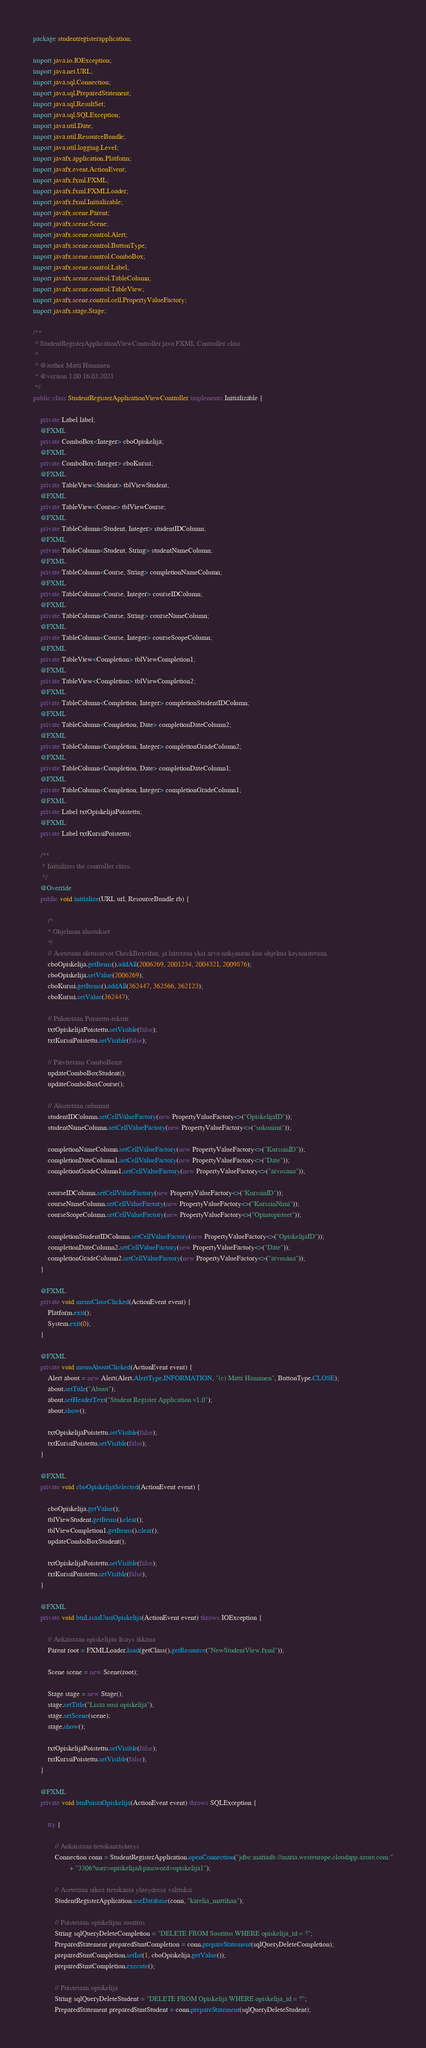<code> <loc_0><loc_0><loc_500><loc_500><_Java_>package studentregisterapplication;

import java.io.IOException;
import java.net.URL;
import java.sql.Connection;
import java.sql.PreparedStatement;
import java.sql.ResultSet;
import java.sql.SQLException;
import java.util.Date;
import java.util.ResourceBundle;
import java.util.logging.Level;
import javafx.application.Platform;
import javafx.event.ActionEvent;
import javafx.fxml.FXML;
import javafx.fxml.FXMLLoader;
import javafx.fxml.Initializable;
import javafx.scene.Parent;
import javafx.scene.Scene;
import javafx.scene.control.Alert;
import javafx.scene.control.ButtonType;
import javafx.scene.control.ComboBox;
import javafx.scene.control.Label;
import javafx.scene.control.TableColumn;
import javafx.scene.control.TableView;
import javafx.scene.control.cell.PropertyValueFactory;
import javafx.stage.Stage;

/**
 * StudentRegisterApplicationViewController.java FXML Controller class
 *
 * @author Matti Hanninen
 * @version 1.00 16.03.2021
 */
public class StudentRegisterApplicationViewController implements Initializable {

    private Label label;
    @FXML
    private ComboBox<Integer> cboOpiskelija;
    @FXML
    private ComboBox<Integer> cboKurssi;
    @FXML
    private TableView<Student> tblViewStudent;
    @FXML
    private TableView<Course> tblViewCourse;
    @FXML
    private TableColumn<Student, Integer> studentIDColumn;
    @FXML
    private TableColumn<Student, String> studentNameColumn;
    @FXML
    private TableColumn<Course, String> completionNameColumn;
    @FXML
    private TableColumn<Course, Integer> courseIDColumn;
    @FXML
    private TableColumn<Course, String> courseNameColumn;
    @FXML
    private TableColumn<Course, Integer> courseScopeColumn;
    @FXML
    private TableView<Completion> tblViewCompletion1;
    @FXML
    private TableView<Completion> tblViewCompletion2;
    @FXML
    private TableColumn<Completion, Integer> completionStudentIDColumn;
    @FXML
    private TableColumn<Completion, Date> completionDateColumn2;
    @FXML
    private TableColumn<Completion, Integer> completionGradeColumn2;
    @FXML
    private TableColumn<Completion, Date> completionDateColumn1;
    @FXML
    private TableColumn<Completion, Integer> completionGradeColumn1;
    @FXML
    private Label txtOpiskelijaPoistettu;
    @FXML
    private Label txtKurssiPoistettu;

    /**
     * Initializes the controller class.
     */
    @Override
    public void initialize(URL url, ResourceBundle rb) {

        /*
        * Ohjelman alustukset
        */
        // Asetetaan oletusarvot CheckBoxeihin, ja laitetaan yksi arvo nakymaan kun ohjelma kaynnistetaan.
        cboOpiskelija.getItems().addAll(2006269, 2001234, 2004321, 2009876);
        cboOpiskelija.setValue(2006269);
        cboKurssi.getItems().addAll(362447, 362566, 362123);
        cboKurssi.setValue(362447);

        // Piilotetaan Poistettu-tekstit
        txtOpiskelijaPoistettu.setVisible(false);
        txtKurssiPoistettu.setVisible(false);

        // Paivitetaan ComboBoxit
        updateComboBoxStudent();
        updateComboBoxCourse();

        // Alustetaan columnit
        studentIDColumn.setCellValueFactory(new PropertyValueFactory<>("OpiskelijaID"));
        studentNameColumn.setCellValueFactory(new PropertyValueFactory<>("sukunimi"));

        completionNameColumn.setCellValueFactory(new PropertyValueFactory<>("KurssinID"));
        completionDateColumn1.setCellValueFactory(new PropertyValueFactory<>("Date"));
        completionGradeColumn1.setCellValueFactory(new PropertyValueFactory<>("arvosana"));

        courseIDColumn.setCellValueFactory(new PropertyValueFactory<>("KurssinID"));
        courseNameColumn.setCellValueFactory(new PropertyValueFactory<>("KurssinNimi"));
        courseScopeColumn.setCellValueFactory(new PropertyValueFactory<>("Opintopisteet"));

        completionStudentIDColumn.setCellValueFactory(new PropertyValueFactory<>("OpiskelijaID"));
        completionDateColumn2.setCellValueFactory(new PropertyValueFactory<>("Date"));
        completionGradeColumn2.setCellValueFactory(new PropertyValueFactory<>("arvosana"));
    }

    @FXML
    private void menuCloseClicked(ActionEvent event) {
        Platform.exit();
        System.exit(0);
    }

    @FXML
    private void menuAboutClicked(ActionEvent event) {
        Alert about = new Alert(Alert.AlertType.INFORMATION, "(c) Matti Hanninen", ButtonType.CLOSE);
        about.setTitle("About");
        about.setHeaderText("Student Register Application v1.0");
        about.show();

        txtOpiskelijaPoistettu.setVisible(false);
        txtKurssiPoistettu.setVisible(false);
    }

    @FXML
    private void cboOpiskelijaSelected(ActionEvent event) {

        cboOpiskelija.getValue();
        tblViewStudent.getItems().clear();
        tblViewCompletion1.getItems().clear();
        updateComboBoxStudent();

        txtOpiskelijaPoistettu.setVisible(false);
        txtKurssiPoistettu.setVisible(false);
    }

    @FXML
    private void btnLisaaUusiOpiskelija(ActionEvent event) throws IOException {

        // Aukaistaan opiskelijan lisays ikkuna
        Parent root = FXMLLoader.load(getClass().getResource("NewStudentView.fxml"));

        Scene scene = new Scene(root);

        Stage stage = new Stage();
        stage.setTitle("Lisaa uusi opiskelija");
        stage.setScene(scene);
        stage.show();

        txtOpiskelijaPoistettu.setVisible(false);
        txtKurssiPoistettu.setVisible(false);
    }

    @FXML
    private void btnPoistaOpiskelija(ActionEvent event) throws SQLException {

        try {

            // Aukaistaan tietokantayhteys
            Connection conn = StudentRegisterApplication.openConnection("jdbc:mariadb://maria.westeurope.cloudapp.azure.com:"
                    + "3306?user=opiskelija&password=opiskelija1");

            // Asetetaan oikea tietokanta yhteydessa valituksi
            StudentRegisterApplication.useDatabase(conn, "karelia_mattihan");

            // Poistetaan opiskelijan suoritus
            String sqlQueryDeleteCompletion = "DELETE FROM Suoritus WHERE opiskelija_id = ?";
            PreparedStatement preparedStmtCompletion = conn.prepareStatement(sqlQueryDeleteCompletion);
            preparedStmtCompletion.setInt(1, cboOpiskelija.getValue());
            preparedStmtCompletion.execute();

            // Poistetaan opiskelija
            String sqlQueryDeleteStudent = "DELETE FROM Opiskelija WHERE opiskelija_id = ?";
            PreparedStatement preparedStmtStudent = conn.prepareStatement(sqlQueryDeleteStudent);</code> 